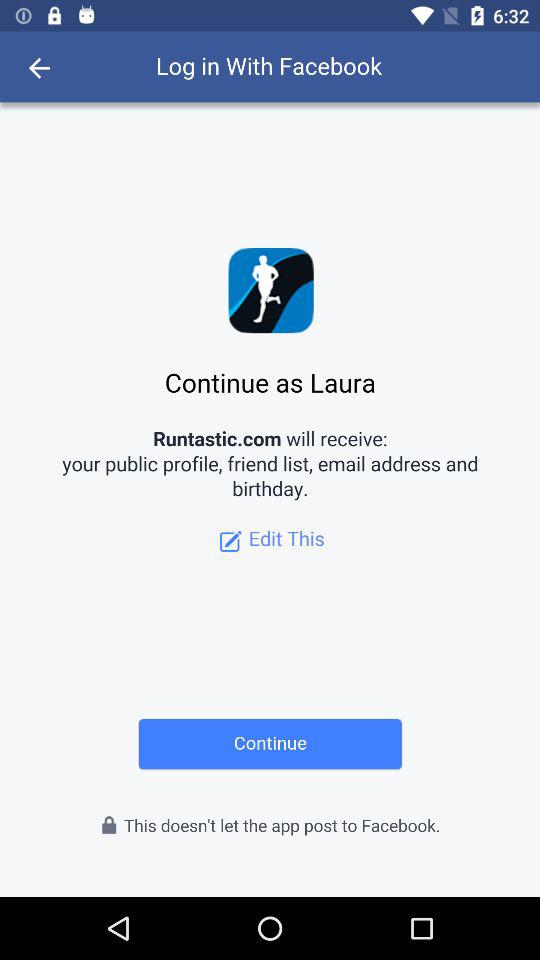What application will receive your public profile, friend list, email address and birthday? The application is "Runtastic.com". 